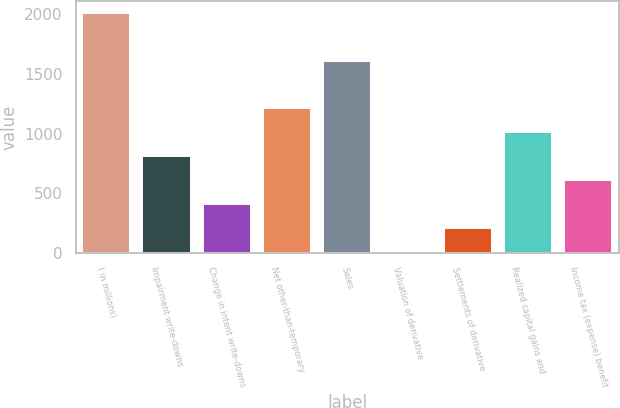<chart> <loc_0><loc_0><loc_500><loc_500><bar_chart><fcel>( in millions)<fcel>Impairment write-downs<fcel>Change in intent write-downs<fcel>Net other-than-temporary<fcel>Sales<fcel>Valuation of derivative<fcel>Settlements of derivative<fcel>Realized capital gains and<fcel>Income tax (expense) benefit<nl><fcel>2012<fcel>811.4<fcel>411.2<fcel>1211.6<fcel>1611.8<fcel>11<fcel>211.1<fcel>1011.5<fcel>611.3<nl></chart> 